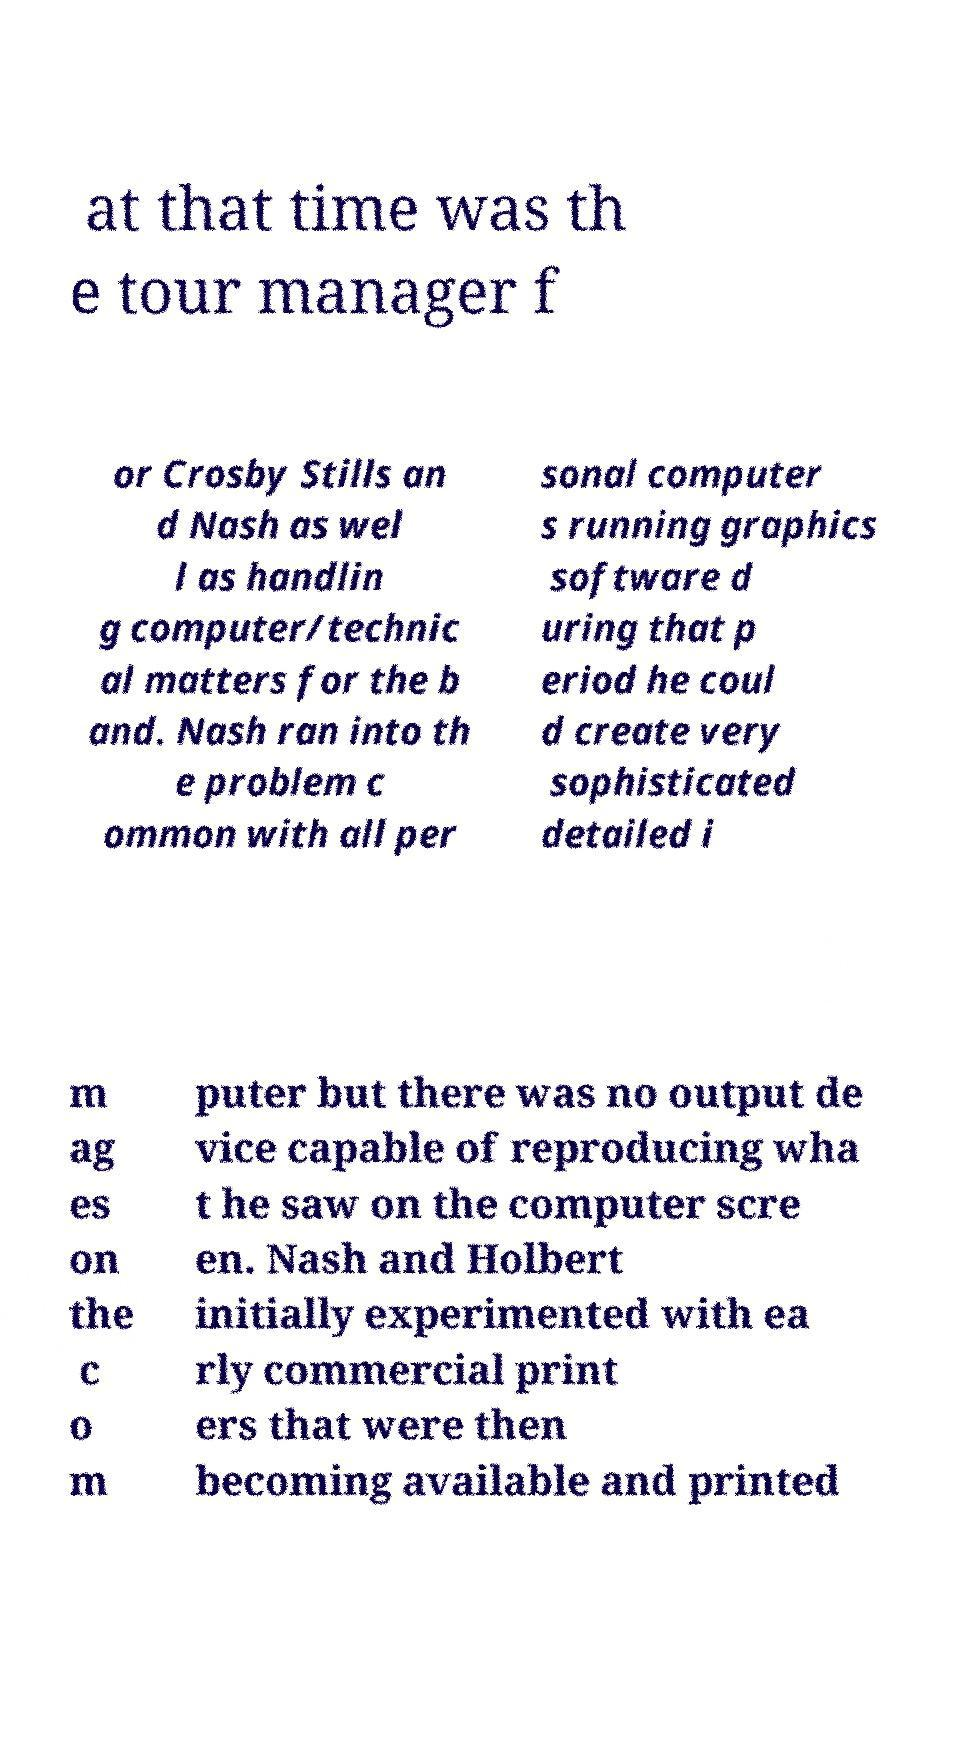There's text embedded in this image that I need extracted. Can you transcribe it verbatim? at that time was th e tour manager f or Crosby Stills an d Nash as wel l as handlin g computer/technic al matters for the b and. Nash ran into th e problem c ommon with all per sonal computer s running graphics software d uring that p eriod he coul d create very sophisticated detailed i m ag es on the c o m puter but there was no output de vice capable of reproducing wha t he saw on the computer scre en. Nash and Holbert initially experimented with ea rly commercial print ers that were then becoming available and printed 